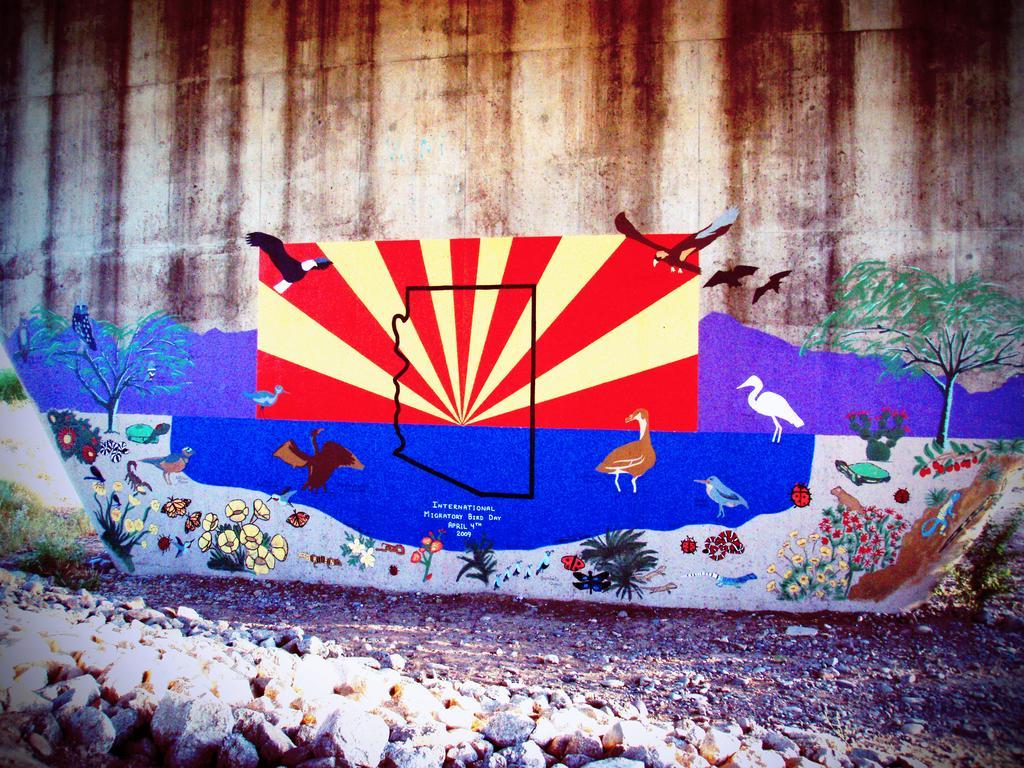Please provide a concise description of this image. In the image we can see there is a wall on which there are the drawings of birds, trees, plants and flowers and insects too. On the ground there are stones. 